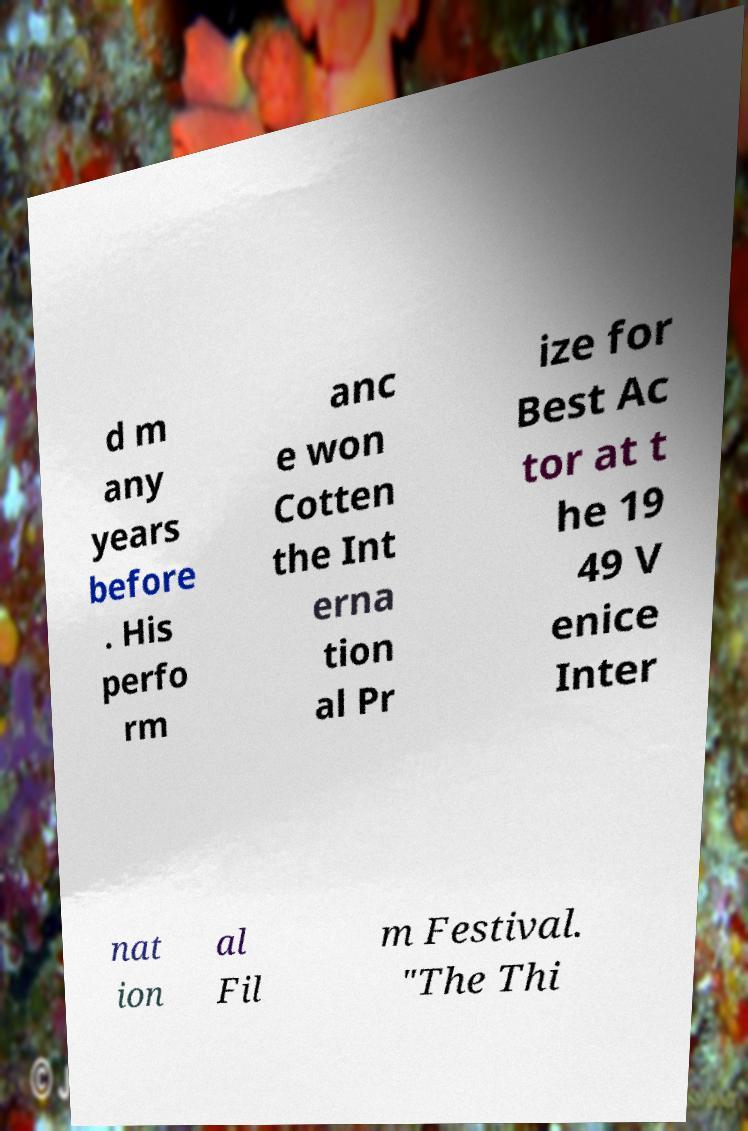What messages or text are displayed in this image? I need them in a readable, typed format. d m any years before . His perfo rm anc e won Cotten the Int erna tion al Pr ize for Best Ac tor at t he 19 49 V enice Inter nat ion al Fil m Festival. "The Thi 